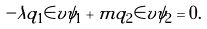Convert formula to latex. <formula><loc_0><loc_0><loc_500><loc_500>- \lambda q _ { 1 } \in v \psi _ { 1 } + m q _ { 2 } \in v \psi _ { 2 } = 0 .</formula> 